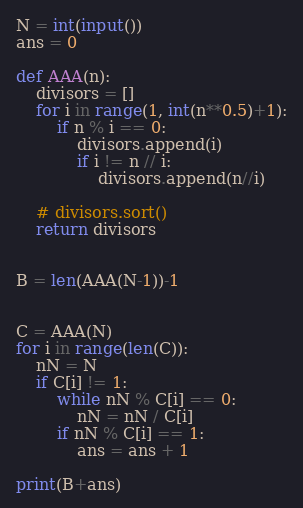<code> <loc_0><loc_0><loc_500><loc_500><_Python_>N = int(input())
ans = 0

def AAA(n):
    divisors = []
    for i in range(1, int(n**0.5)+1):
        if n % i == 0:
            divisors.append(i)
            if i != n // i:
                divisors.append(n//i)

    # divisors.sort()
    return divisors


B = len(AAA(N-1))-1


C = AAA(N)
for i in range(len(C)):
    nN = N
    if C[i] != 1:
        while nN % C[i] == 0:
            nN = nN / C[i]
        if nN % C[i] == 1:
            ans = ans + 1
            
print(B+ans)</code> 